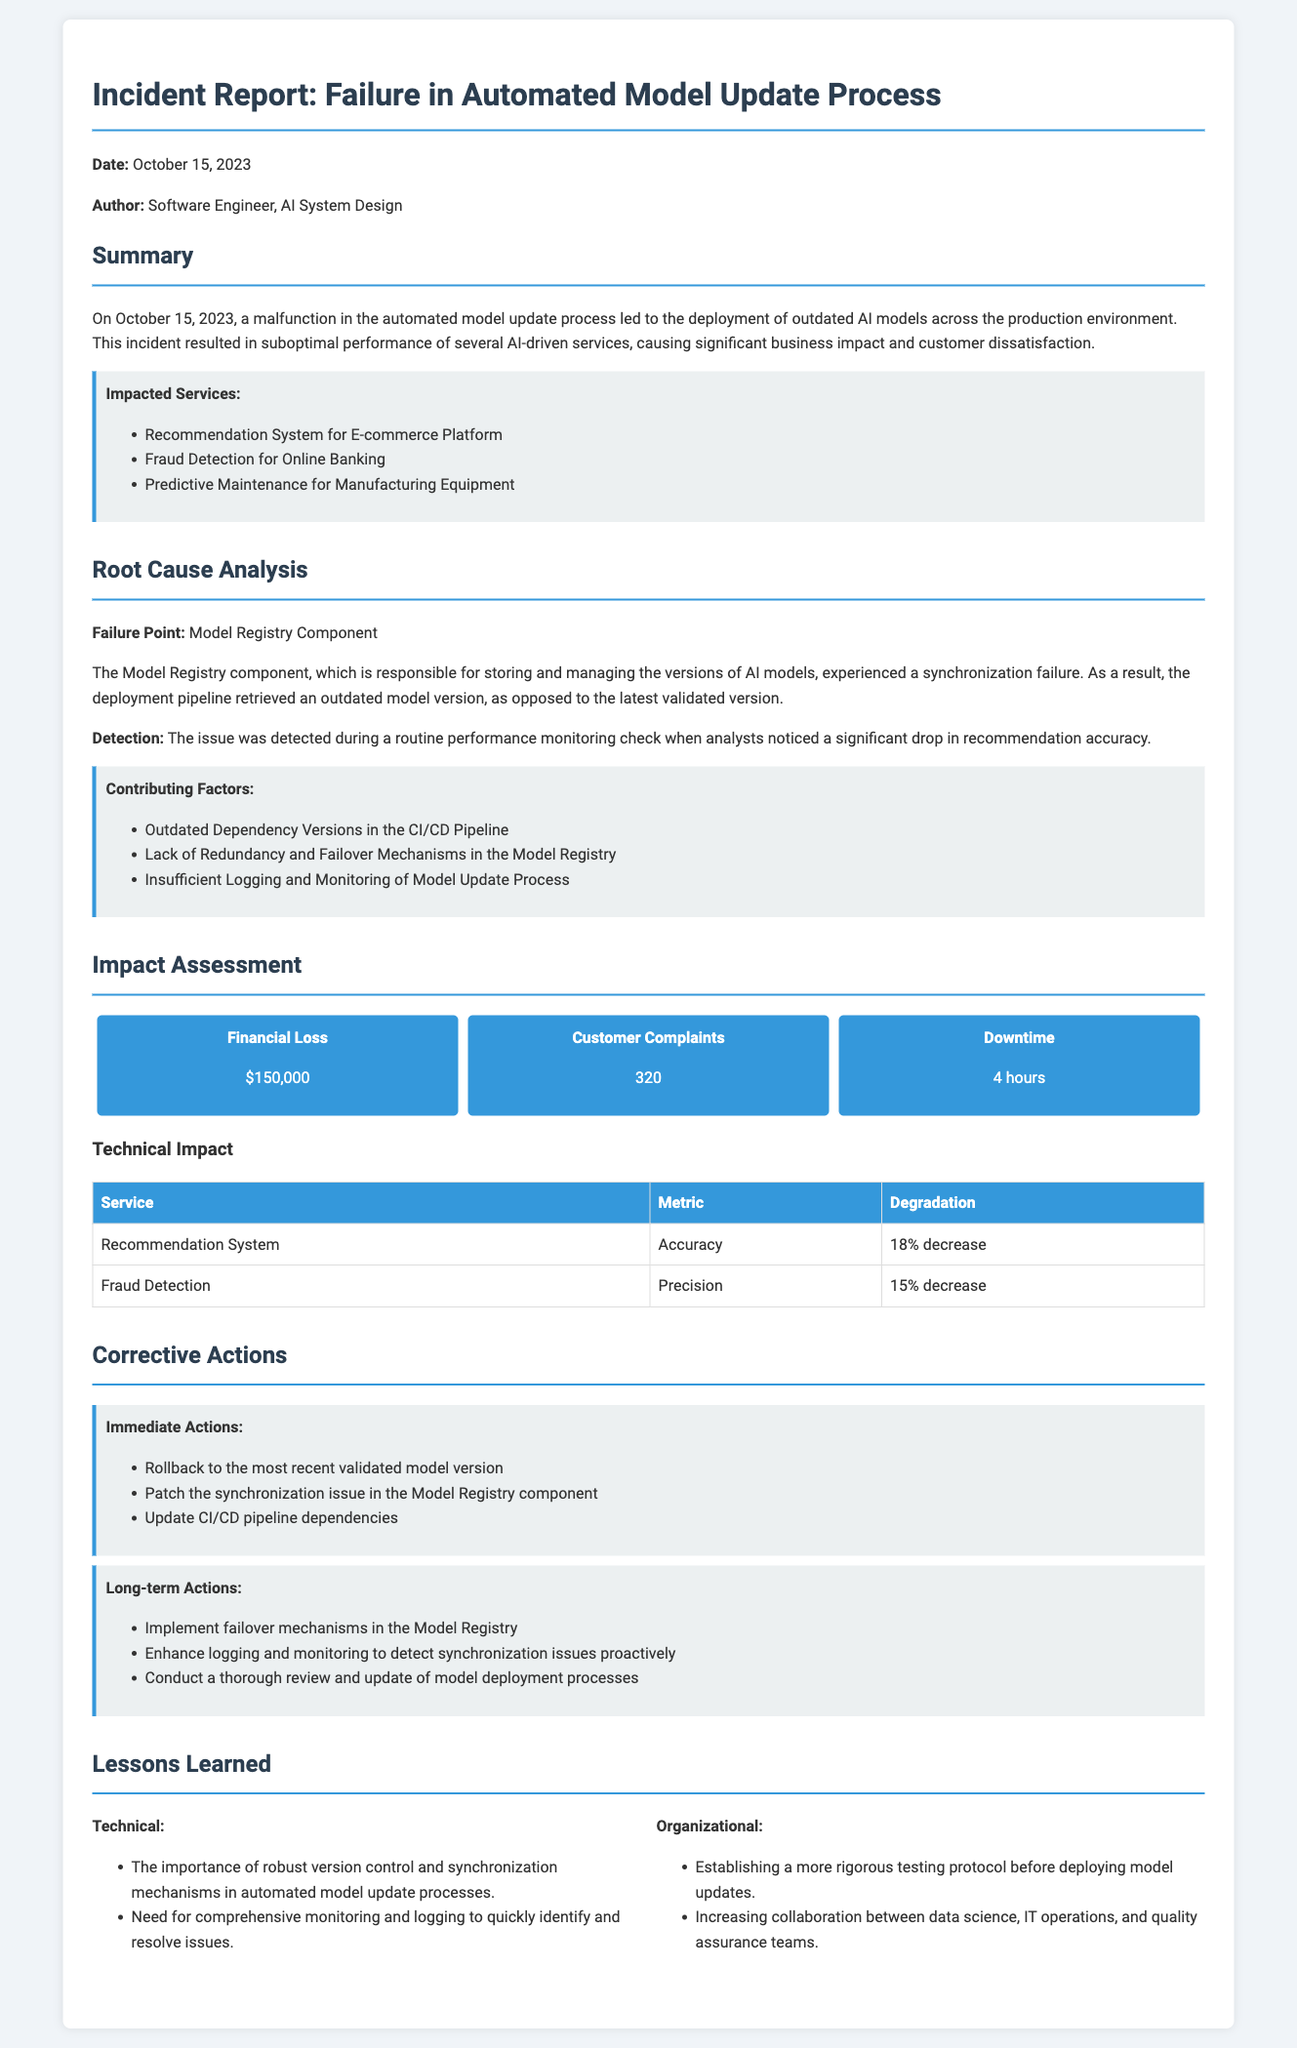What was the date of the incident? The date of the incident is mentioned at the beginning of the report as October 15, 2023.
Answer: October 15, 2023 Who authored the report? The author of the report is specified as Software Engineer, AI System Design.
Answer: Software Engineer, AI System Design What triggered the detection of the issue? The issue was detected during a routine performance monitoring check, specifically when analysts noticed a drop in recommendation accuracy.
Answer: Significant drop in recommendation accuracy How many customer complaints were reported? The report states that there were 320 customer complaints as a result of the incident.
Answer: 320 What is one contributing factor to the incident? One of the contributing factors listed is outdated dependency versions in the CI/CD pipeline.
Answer: Outdated Dependency Versions in the CI/CD Pipeline What was the financial loss due to the incident? The report outlines the financial loss as $150,000 due to the performance issues.
Answer: $150,000 What are immediate actions taken post-incident? Immediate actions include rolling back to the most recent validated model version, among others.
Answer: Rollback to the most recent validated model version What lesson related to technical aspects was learned? One technical lesson learned is the importance of robust version control and synchronization mechanisms in automated model update processes.
Answer: Importance of robust version control and synchronization mechanisms What long-term action involves improving model registry? A long-term action proposed is to implement failover mechanisms in the Model Registry.
Answer: Implement failover mechanisms in the Model Registry 